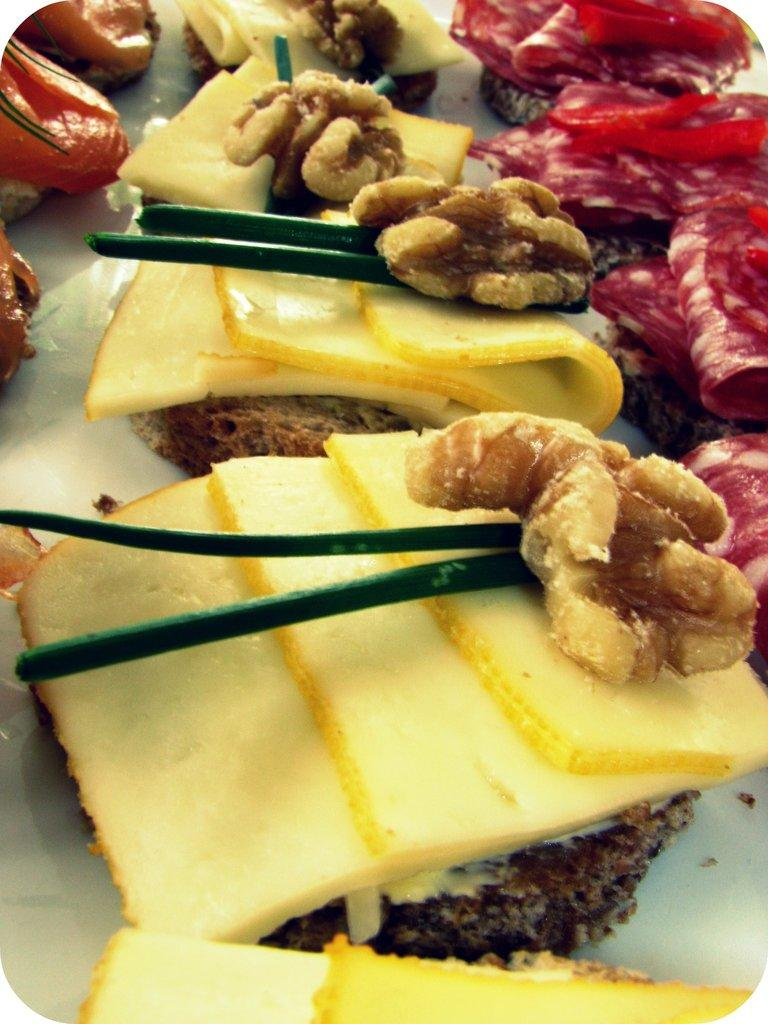What is placed on the table in the image? There is food placed on a table in the image. What type of volleyball can be seen in the image? There is no volleyball present in the image; it features food placed on a table. What type of fuel is being used to cook the food in the image? The image does not show any cooking or fuel being used; it only shows food placed on a table. 